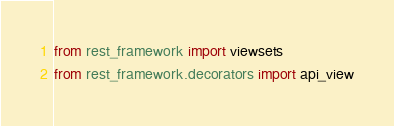Convert code to text. <code><loc_0><loc_0><loc_500><loc_500><_Python_>from rest_framework import viewsets
from rest_framework.decorators import api_view</code> 